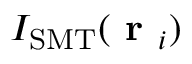<formula> <loc_0><loc_0><loc_500><loc_500>I _ { S M T } ( r _ { i } )</formula> 